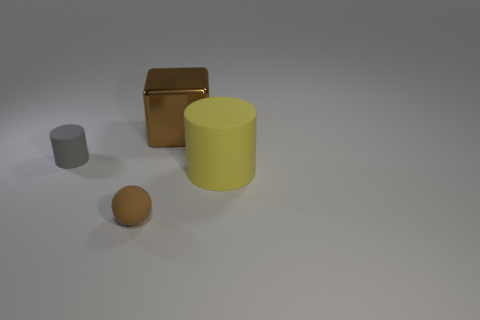The big object that is the same color as the tiny rubber ball is what shape?
Your answer should be very brief. Cube. Does the yellow thing have the same size as the gray object?
Your response must be concise. No. Is the shape of the gray object the same as the big brown object?
Keep it short and to the point. No. What number of other things are the same material as the big brown thing?
Your answer should be very brief. 0. Is the size of the rubber cylinder that is right of the gray rubber object the same as the matte cylinder on the left side of the big yellow object?
Offer a terse response. No. How many things are tiny things in front of the small matte cylinder or objects that are in front of the big yellow matte cylinder?
Offer a terse response. 1. Is there anything else that has the same shape as the tiny brown rubber object?
Make the answer very short. No. There is a big thing that is on the left side of the large cylinder; is its color the same as the tiny thing in front of the yellow matte cylinder?
Give a very brief answer. Yes. How many rubber objects are either brown objects or big cylinders?
Offer a terse response. 2. There is a small gray thing in front of the big thing that is behind the gray object; what is its shape?
Provide a short and direct response. Cylinder. 